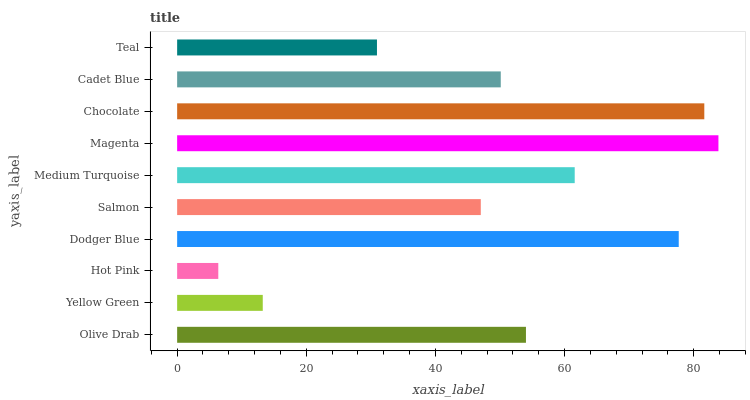Is Hot Pink the minimum?
Answer yes or no. Yes. Is Magenta the maximum?
Answer yes or no. Yes. Is Yellow Green the minimum?
Answer yes or no. No. Is Yellow Green the maximum?
Answer yes or no. No. Is Olive Drab greater than Yellow Green?
Answer yes or no. Yes. Is Yellow Green less than Olive Drab?
Answer yes or no. Yes. Is Yellow Green greater than Olive Drab?
Answer yes or no. No. Is Olive Drab less than Yellow Green?
Answer yes or no. No. Is Olive Drab the high median?
Answer yes or no. Yes. Is Cadet Blue the low median?
Answer yes or no. Yes. Is Chocolate the high median?
Answer yes or no. No. Is Olive Drab the low median?
Answer yes or no. No. 